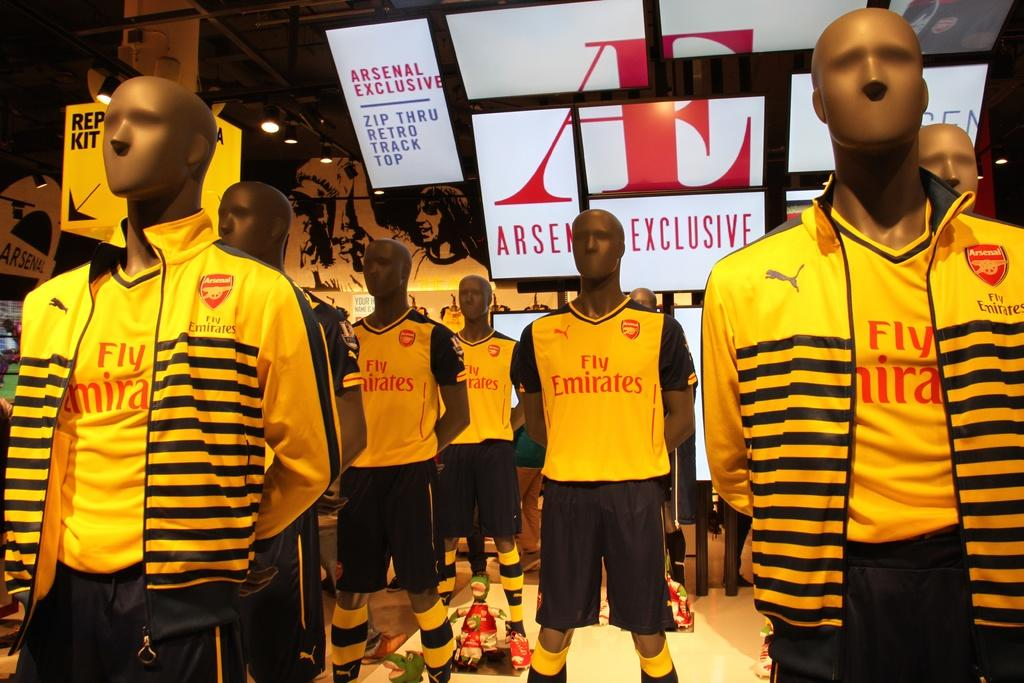Provide a one-sentence caption for the provided image. Mannequins wearing yellow and black apparel with Emirates logo. 